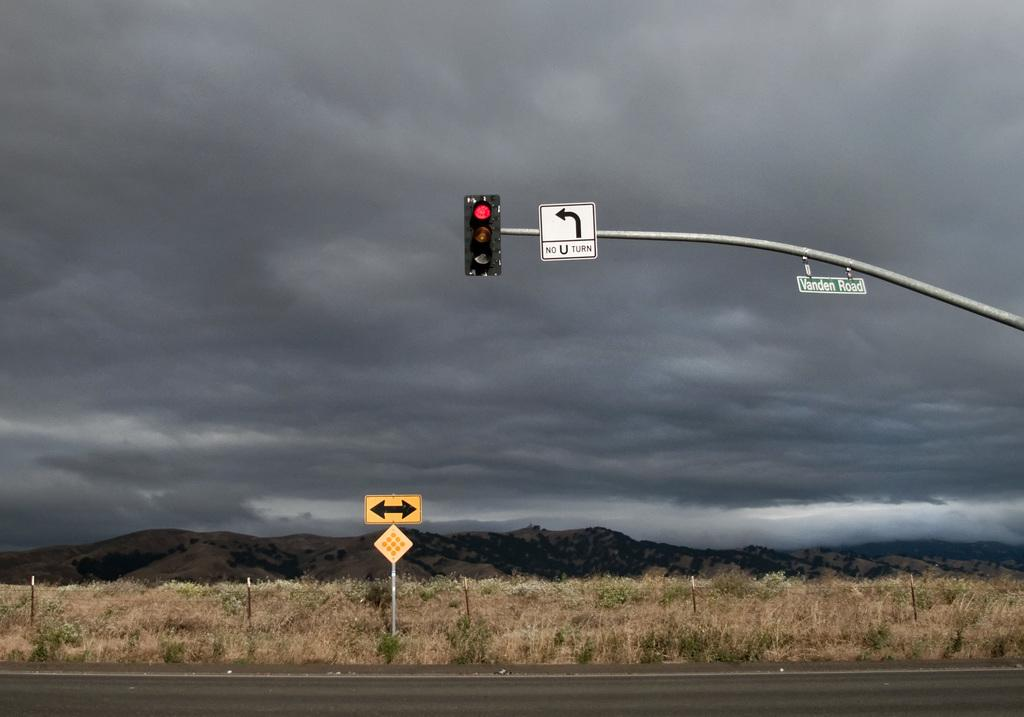What is located in the middle of the image? There is a traffic signal, a sign board, a text board, and a pole in the middle of the image. What is present at the bottom of the image? At the bottom of the image, there is a signboard, a pole, grass, and a road. What can be seen in the background of the image? Hills, sky, and clouds are visible in the background of the image. Can you tell me how many people are crying in the image? There are no people present in the image, so it is not possible to determine if anyone is crying. What type of drink is being served in the image? There is no drink or any indication of a drink being served in the image. 